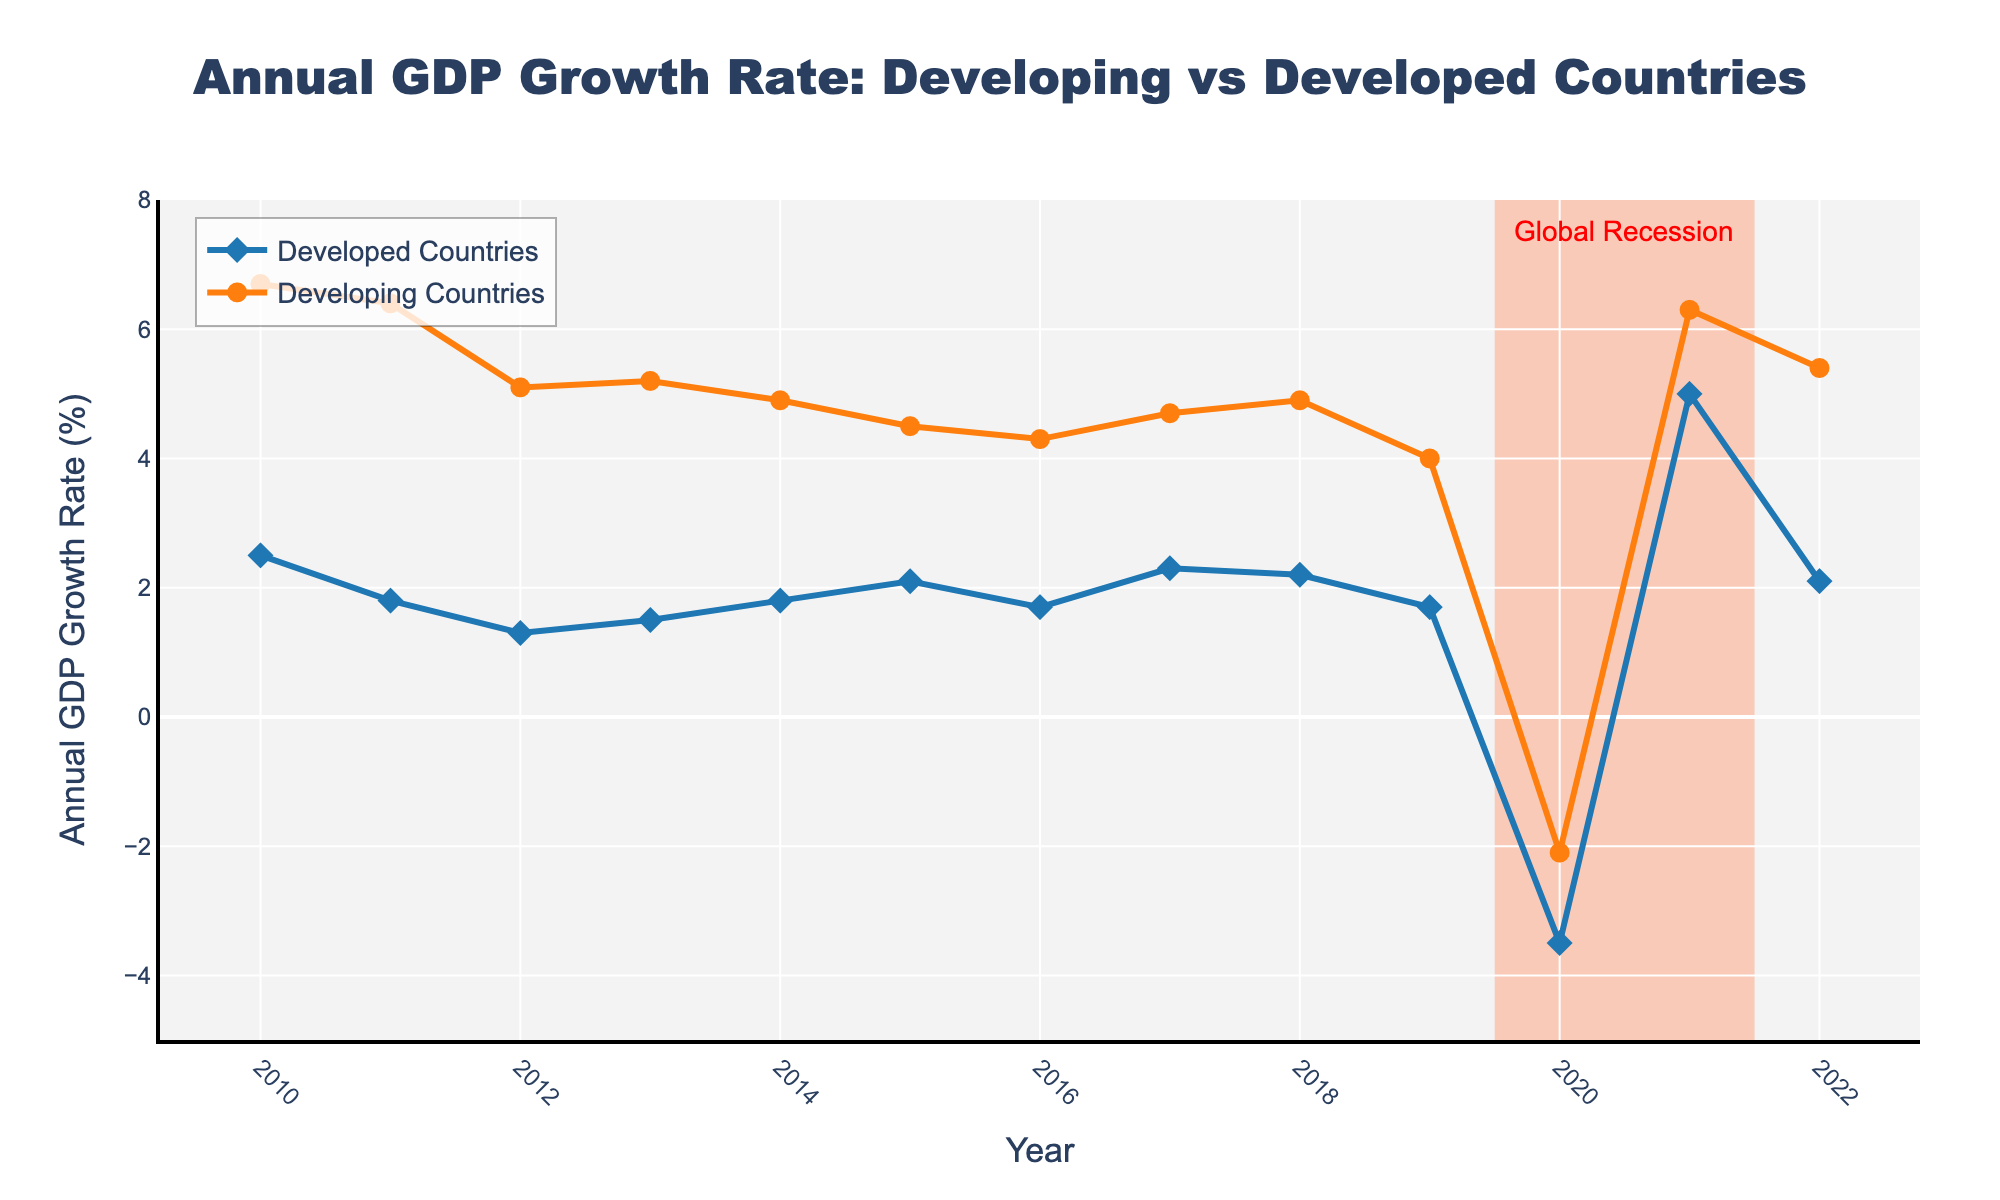what is the title of the plot? The title is displayed at the top center of the plot. It reads "Annual GDP Growth Rate: Developing vs Developed Countries".
Answer: Annual GDP Growth Rate: Developing vs Developed Countries how many years does the plot cover? The x-axis shows the range of years from 2010 to 2022, so the plot covers 13 years.
Answer: 13 during which year did developed countries experience the lowest GDP growth rate? The plot shows that the lowest GDP growth rate for developed countries occurred in 2020, marked by a significant drop.
Answer: 2020 compare the GDP growth rate of developing and developed countries in 2021. which one was higher? The plot shows that the GDP growth rate for developing countries in 2021 was 6.3%, while for developed countries it was 5.0%. Therefore, the GDP growth rate for developing countries was higher.
Answer: developing countries in which year did both country groups experience negative GDP growth rates? By looking at the y-axis, we can observe that both developed and developing countries had negative GDP growth rates in 2020. This is indicated by the lines dipping below 0%.
Answer: 2020 what is the overall trend of GDP growth rates for developing countries from 2010 to 2022? The plot shows that from 2010 to 2022, developing countries generally experienced a decreasing trend in GDP growth rates, with some fluctuations and a notable dip in 2020.
Answer: decreasing between which years did developing countries experience the biggest drop in GDP growth rate? Observing the y-axis values, the biggest drop in GDP growth rate for developing countries occurred between 2011 and 2012, where it fell from 6.4% to 5.1%.
Answer: 2011-2012 what additional information is highlighted on the plot regarding global events? The plot includes a shaded area and an annotation labeled "Global Recession" around the years 2019.5 to 2021.5, indicating the global recession period.
Answer: global recession calculate the average GDP growth rate for developed countries from 2010 to 2022. To calculate the average, sum up the growth rates for each year and then divide by the number of years. The values are: 2.5, 1.8, 1.3, 1.5, 1.8, 2.1, 1.7, 2.3, 2.2, 1.7, -3.5, 5.0, 2.1. The sum is 22.5. Therefore, the average is 22.5 / 13 ≈ 1.73%.
Answer: 1.73% in which year did developing countries experience a higher GDP growth rate compared to the previous year, following a period of decline? In 2021, developing countries experienced a growth rate of 6.3% following a decline to -2.1% in 2020, marking an increase from the previous year.
Answer: 2021 